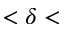<formula> <loc_0><loc_0><loc_500><loc_500>< \delta <</formula> 